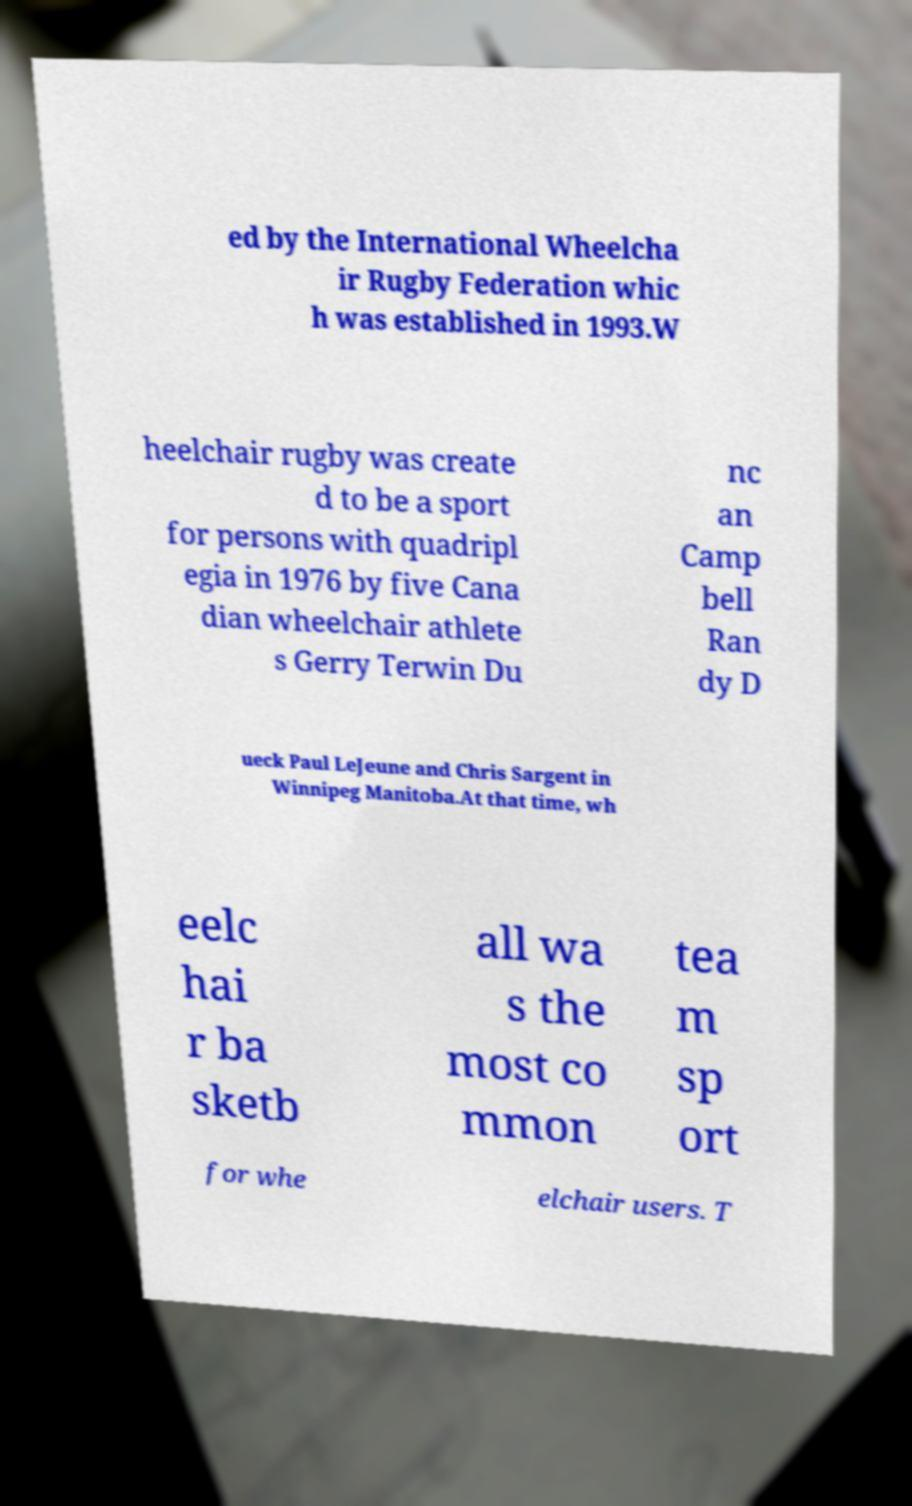I need the written content from this picture converted into text. Can you do that? ed by the International Wheelcha ir Rugby Federation whic h was established in 1993.W heelchair rugby was create d to be a sport for persons with quadripl egia in 1976 by five Cana dian wheelchair athlete s Gerry Terwin Du nc an Camp bell Ran dy D ueck Paul LeJeune and Chris Sargent in Winnipeg Manitoba.At that time, wh eelc hai r ba sketb all wa s the most co mmon tea m sp ort for whe elchair users. T 